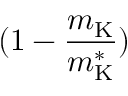Convert formula to latex. <formula><loc_0><loc_0><loc_500><loc_500>( 1 - \frac { m _ { K } } { m _ { K } ^ { * } } )</formula> 